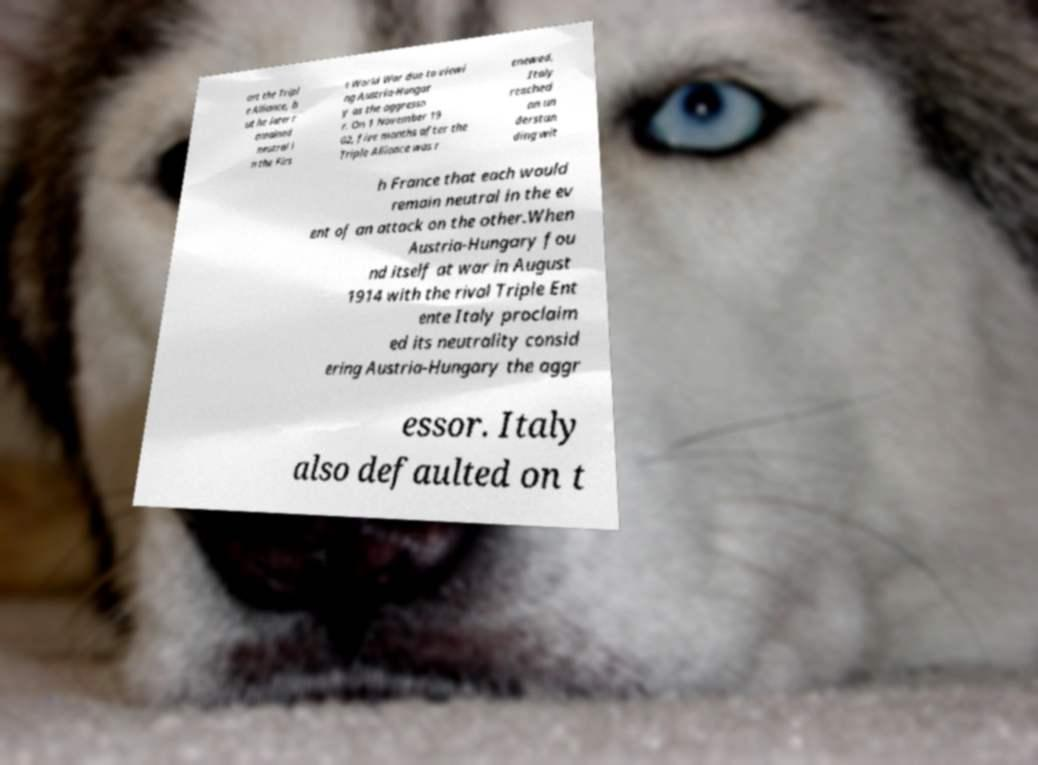Could you assist in decoding the text presented in this image and type it out clearly? ort the Tripl e Alliance, b ut he later r emained neutral i n the Firs t World War due to viewi ng Austria-Hungar y as the aggresso r. On 1 November 19 02, five months after the Triple Alliance was r enewed, Italy reached an un derstan ding wit h France that each would remain neutral in the ev ent of an attack on the other.When Austria-Hungary fou nd itself at war in August 1914 with the rival Triple Ent ente Italy proclaim ed its neutrality consid ering Austria-Hungary the aggr essor. Italy also defaulted on t 